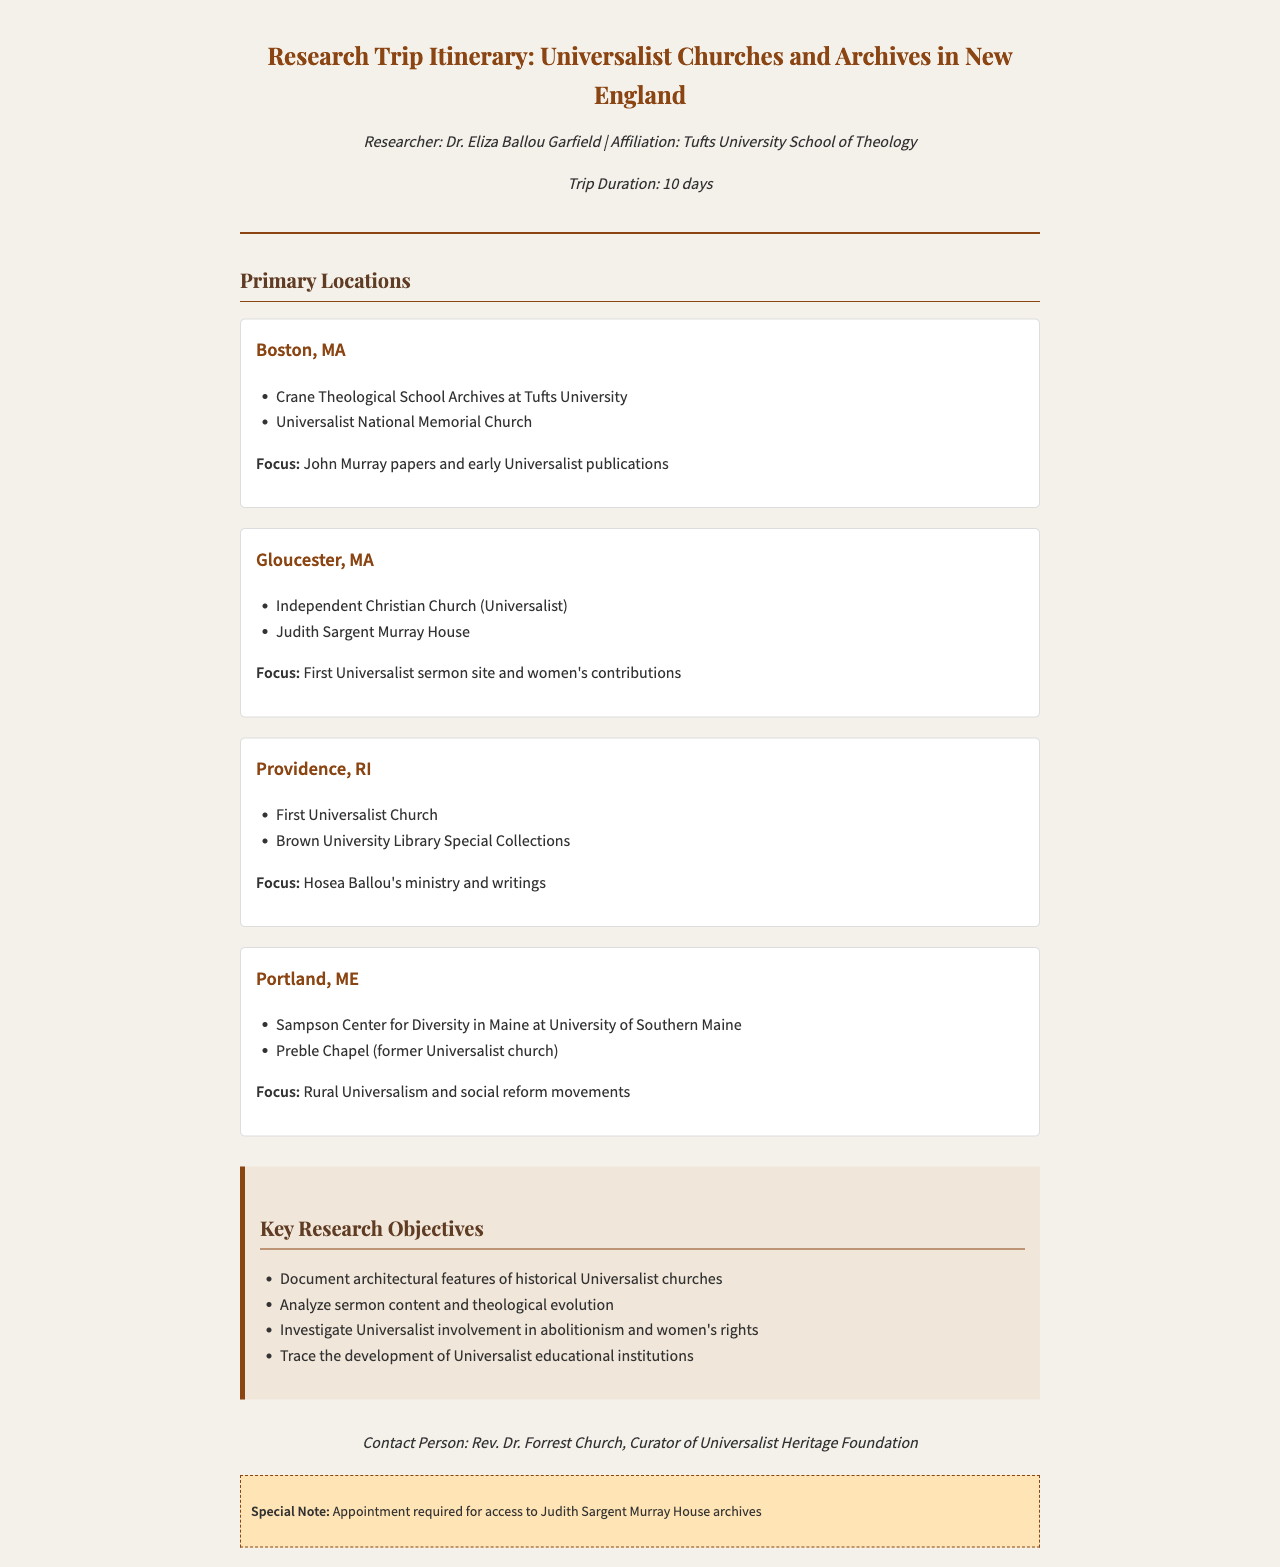What is the duration of the trip? The document explicitly states the Trip Duration as 10 days.
Answer: 10 days Who is the researcher? The researcher is mentioned in the document as Dr. Eliza Ballou Garfield.
Answer: Dr. Eliza Ballou Garfield Which church is located in Boston, MA? The document lists the Universalist National Memorial Church among other locations in Boston, MA.
Answer: Universalist National Memorial Church What is the primary focus in Gloucester, MA? The focus in Gloucester, MA is detailed as First Universalist sermon site and women's contributions.
Answer: First Universalist sermon site and women's contributions Which university's library is mentioned in Providence, RI? The Brown University Library Special Collections is mentioned as a location in Providence, RI.
Answer: Brown University Library Special Collections How many key research objectives are listed? The document lists four key research objectives in the specified section.
Answer: 4 What is required for access to the Judith Sargent Murray House archives? The document states that an appointment is required.
Answer: Appointment Who is the contact person for the trip? The contact person provided in the document is Rev. Dr. Forrest Church.
Answer: Rev. Dr. Forrest Church What city is associated with rural Universalism and social reform movements? Portland, ME is identified as the location focused on rural Universalism and social reform movements.
Answer: Portland, ME 